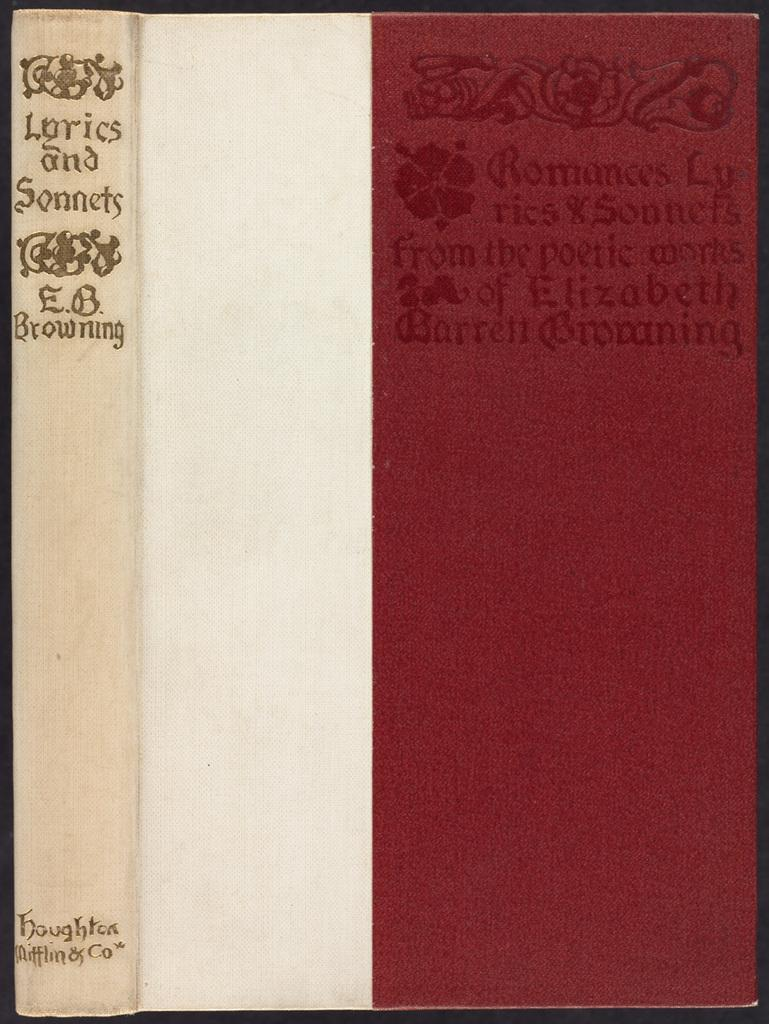Provide a one-sentence caption for the provided image. The books contains a collection of lyrics and sonnets. 